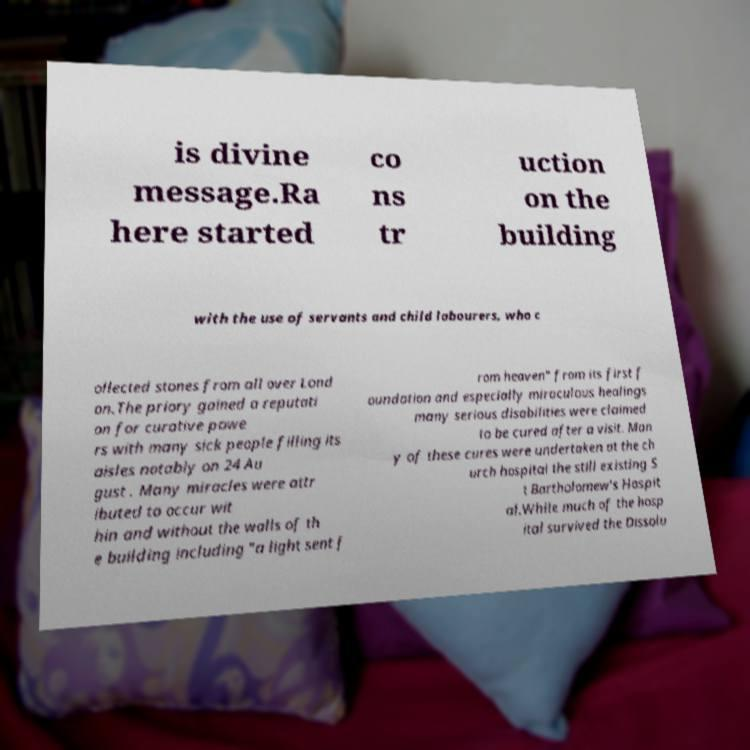Could you extract and type out the text from this image? is divine message.Ra here started co ns tr uction on the building with the use of servants and child labourers, who c ollected stones from all over Lond on.The priory gained a reputati on for curative powe rs with many sick people filling its aisles notably on 24 Au gust . Many miracles were attr ibuted to occur wit hin and without the walls of th e building including "a light sent f rom heaven" from its first f oundation and especially miraculous healings many serious disabilities were claimed to be cured after a visit. Man y of these cures were undertaken at the ch urch hospital the still existing S t Bartholomew's Hospit al.While much of the hosp ital survived the Dissolu 